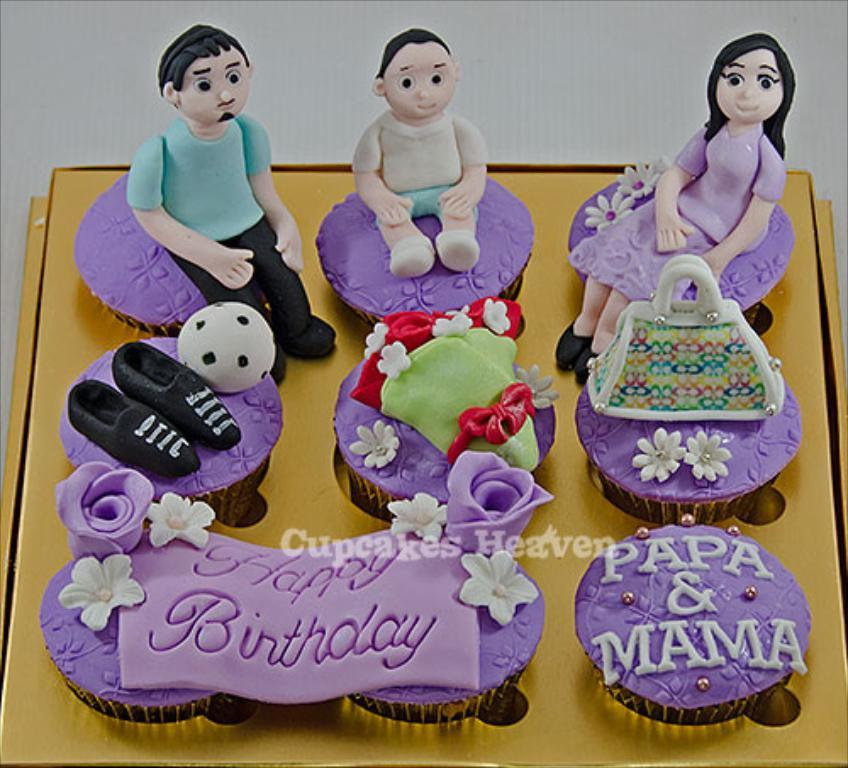What type of food can be seen in the image? There are cupcakes in the image. What other objects are present in the image besides the cupcakes? There are animated toys in the image. What type of punishment is the squirrel receiving in the image? There is no squirrel present in the image, so it is not possible to determine if any punishment is being received. 